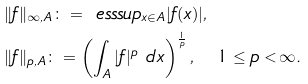<formula> <loc_0><loc_0><loc_500><loc_500>& \| f \| _ { \infty , A } \colon = \ e s s s u p _ { x \in A } | f ( x ) | , \\ & \| f \| _ { p , A } \colon = \left ( \int _ { A } | f | ^ { p } \ d x \right ) ^ { \frac { 1 } { p } } , \quad 1 \leq p < \infty .</formula> 